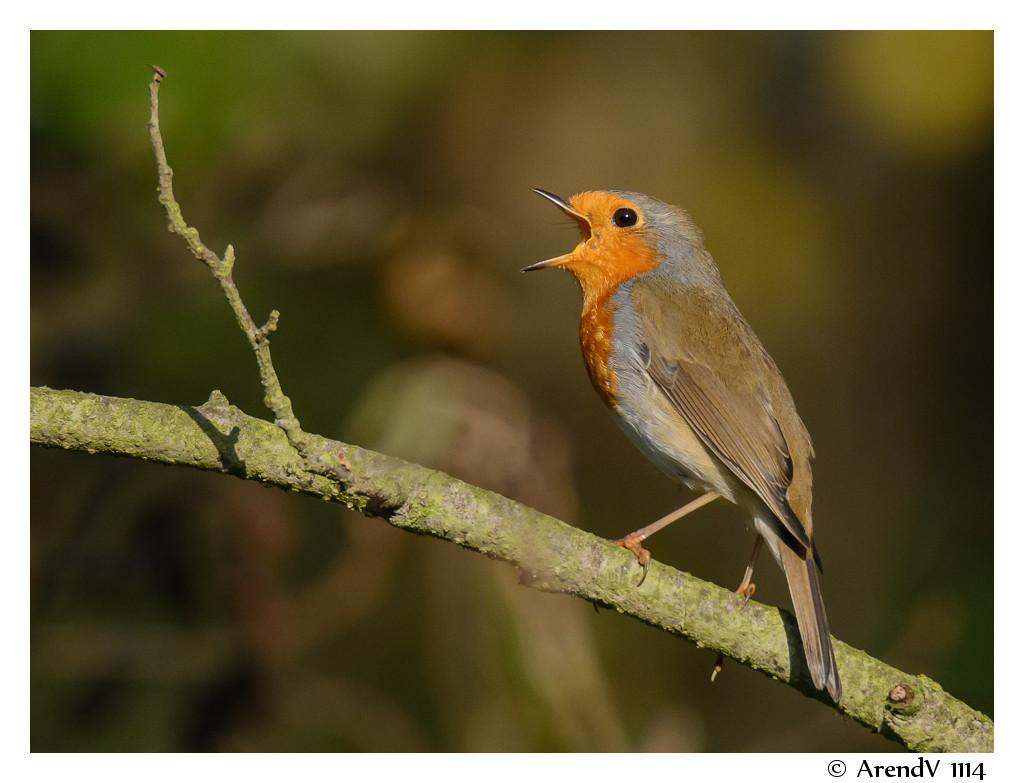What type of animal is in the image? There is a bird in the image. Where is the bird located? The bird is standing on a tree branch. What is the bird doing with its mouth? The bird has its mouth open. What is in front of the bird? There is a watermark in front of the bird. What type of hope can be seen in the image? There is no reference to hope in the image; it features a bird standing on a tree branch with its mouth open and a watermark in front of it. 